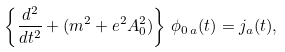Convert formula to latex. <formula><loc_0><loc_0><loc_500><loc_500>\left \{ \frac { d ^ { 2 } } { d t ^ { 2 } } + ( m ^ { 2 } + e ^ { 2 } A _ { 0 } ^ { 2 } ) \right \} \, \phi _ { 0 \, a } ( t ) = j _ { a } ( t ) ,</formula> 